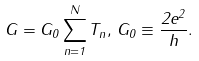Convert formula to latex. <formula><loc_0><loc_0><loc_500><loc_500>G = G _ { 0 } \sum _ { n = 1 } ^ { N } T _ { n } , \, G _ { 0 } \equiv \frac { 2 e ^ { 2 } } { h } .</formula> 